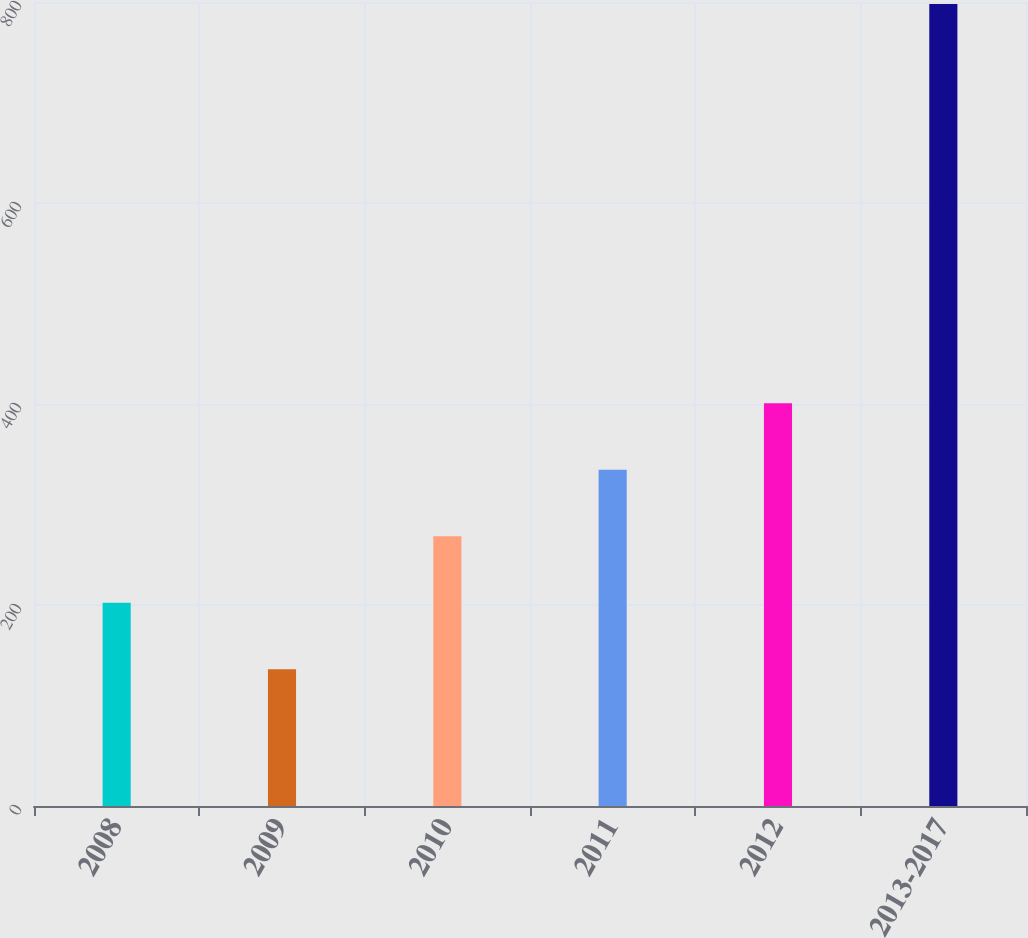<chart> <loc_0><loc_0><loc_500><loc_500><bar_chart><fcel>2008<fcel>2009<fcel>2010<fcel>2011<fcel>2012<fcel>2013-2017<nl><fcel>202.2<fcel>136<fcel>268.4<fcel>334.6<fcel>400.8<fcel>798<nl></chart> 